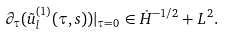<formula> <loc_0><loc_0><loc_500><loc_500>\partial _ { \tau } ( \tilde { u } _ { l } ^ { ( 1 ) } ( \tau , s ) ) | _ { \tau = 0 } \in \dot { H } ^ { - 1 / 2 } + L ^ { 2 } .</formula> 